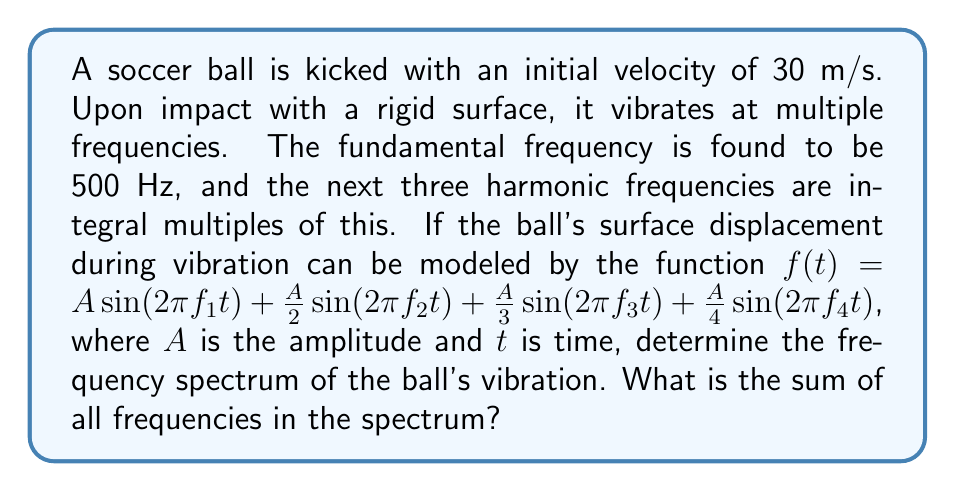Show me your answer to this math problem. To solve this problem, we need to follow these steps:

1) First, let's identify the frequencies:
   - The fundamental frequency $f_1 = 500$ Hz
   - The next three harmonic frequencies are integral multiples of this

2) Calculate the harmonic frequencies:
   - $f_2 = 2 \times 500 = 1000$ Hz
   - $f_3 = 3 \times 500 = 1500$ Hz
   - $f_4 = 4 \times 500 = 2000$ Hz

3) The frequency spectrum consists of these four frequencies:
   $\{500, 1000, 1500, 2000\}$ Hz

4) To find the sum of all frequencies in the spectrum:
   $$\sum_{i=1}^4 f_i = 500 + 1000 + 1500 + 2000 = 5000$$ Hz

Note: In spectral analysis, we would typically also consider the amplitude of each frequency component. In this case, the amplitudes are $A$, $\frac{A}{2}$, $\frac{A}{3}$, and $\frac{A}{4}$ for $f_1$, $f_2$, $f_3$, and $f_4$ respectively. However, the question only asks for the sum of frequencies, not their amplitudes.
Answer: 5000 Hz 